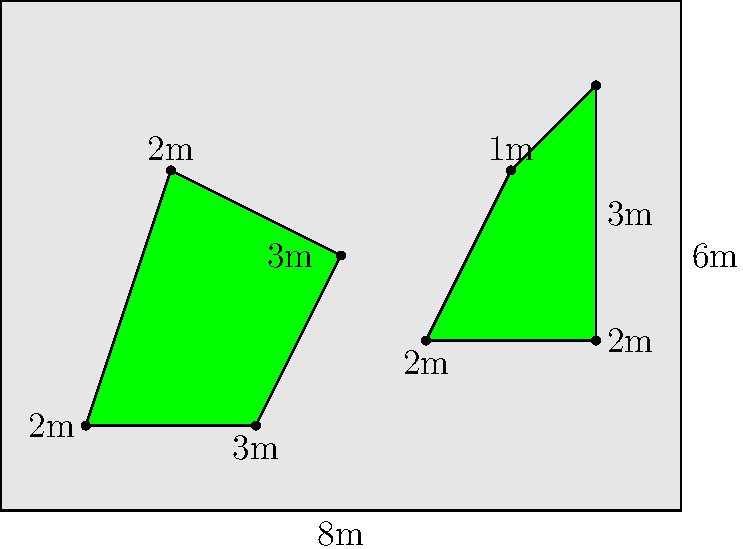A new bike lane project includes two irregular-shaped green spaces along the route. The bike path forms a rectangle of 8m by 6m. Green space A is formed by connecting points (1,1), (3,1), (4,3), and (2,4). Green space B is formed by connecting points (5,2), (7,2), (7,5), and (6,4). What is the total area of both green spaces combined? To solve this problem, we need to calculate the areas of both irregular shapes and add them together. We can break down each shape into simpler geometric forms:

1. For Green space A:
   - It can be divided into a rectangle and a triangle
   - Rectangle: 2m x 2m = 4 sq m
   - Triangle: base = 1m, height = 2m, Area = $\frac{1}{2} \times 1 \times 2 = 1$ sq m
   - Total area of A = 4 + 1 = 5 sq m

2. For Green space B:
   - It can be seen as a rectangle with a small triangle removed
   - Rectangle: 2m x 3m = 6 sq m
   - Triangle to remove: base = 1m, height = 1m, Area = $\frac{1}{2} \times 1 \times 1 = 0.5$ sq m
   - Total area of B = 6 - 0.5 = 5.5 sq m

3. Total combined area:
   Area A + Area B = 5 sq m + 5.5 sq m = 10.5 sq m
Answer: 10.5 sq m 